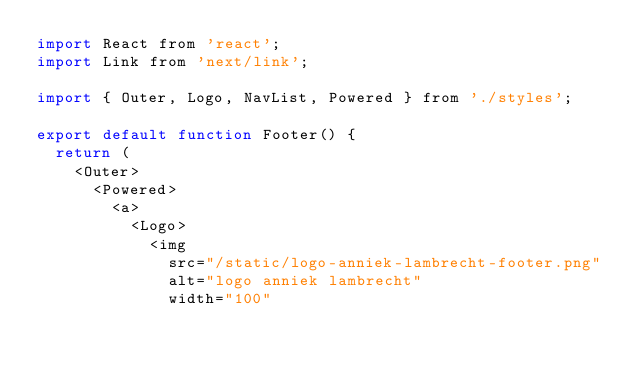Convert code to text. <code><loc_0><loc_0><loc_500><loc_500><_JavaScript_>import React from 'react';
import Link from 'next/link';

import { Outer, Logo, NavList, Powered } from './styles';

export default function Footer() {
  return (
    <Outer>
      <Powered>
        <a>
          <Logo>
            <img
              src="/static/logo-anniek-lambrecht-footer.png"
              alt="logo anniek lambrecht"
              width="100"</code> 